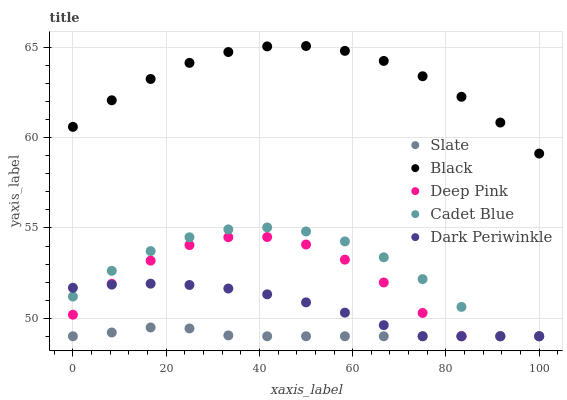Does Slate have the minimum area under the curve?
Answer yes or no. Yes. Does Black have the maximum area under the curve?
Answer yes or no. Yes. Does Deep Pink have the minimum area under the curve?
Answer yes or no. No. Does Deep Pink have the maximum area under the curve?
Answer yes or no. No. Is Slate the smoothest?
Answer yes or no. Yes. Is Deep Pink the roughest?
Answer yes or no. Yes. Is Deep Pink the smoothest?
Answer yes or no. No. Is Slate the roughest?
Answer yes or no. No. Does Cadet Blue have the lowest value?
Answer yes or no. Yes. Does Black have the lowest value?
Answer yes or no. No. Does Black have the highest value?
Answer yes or no. Yes. Does Deep Pink have the highest value?
Answer yes or no. No. Is Dark Periwinkle less than Black?
Answer yes or no. Yes. Is Black greater than Deep Pink?
Answer yes or no. Yes. Does Cadet Blue intersect Dark Periwinkle?
Answer yes or no. Yes. Is Cadet Blue less than Dark Periwinkle?
Answer yes or no. No. Is Cadet Blue greater than Dark Periwinkle?
Answer yes or no. No. Does Dark Periwinkle intersect Black?
Answer yes or no. No. 